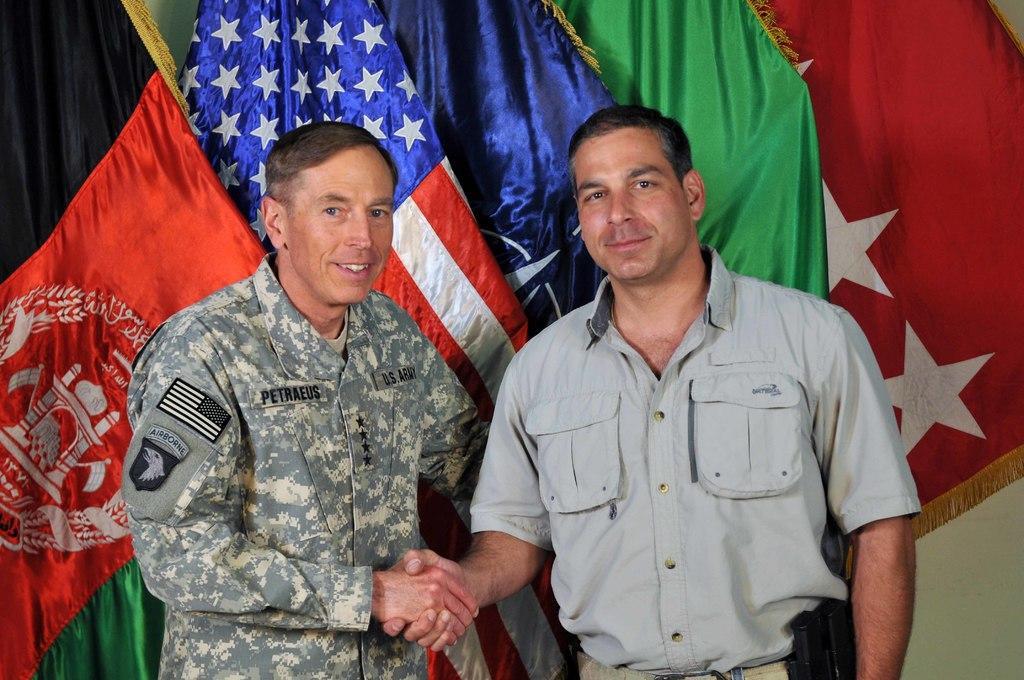Could you give a brief overview of what you see in this image? This picture seems to be clicked inside. In the center there are two persons, smiling, standing on the ground and shaking their hands. In the background we can see the different colors of flags and a wall. 